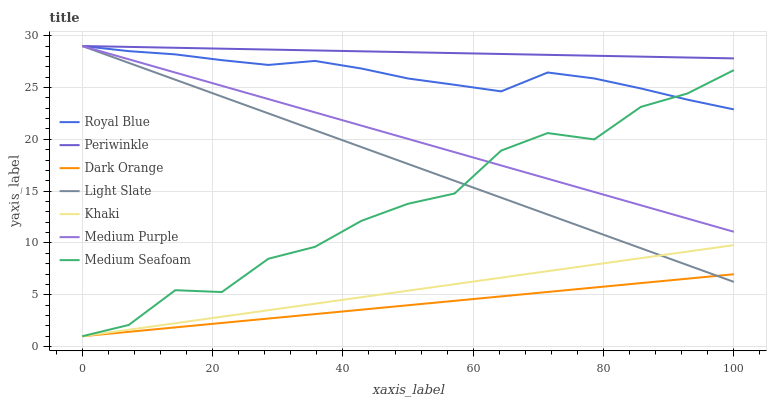Does Khaki have the minimum area under the curve?
Answer yes or no. No. Does Khaki have the maximum area under the curve?
Answer yes or no. No. Is Khaki the smoothest?
Answer yes or no. No. Is Khaki the roughest?
Answer yes or no. No. Does Light Slate have the lowest value?
Answer yes or no. No. Does Khaki have the highest value?
Answer yes or no. No. Is Khaki less than Periwinkle?
Answer yes or no. Yes. Is Royal Blue greater than Dark Orange?
Answer yes or no. Yes. Does Khaki intersect Periwinkle?
Answer yes or no. No. 